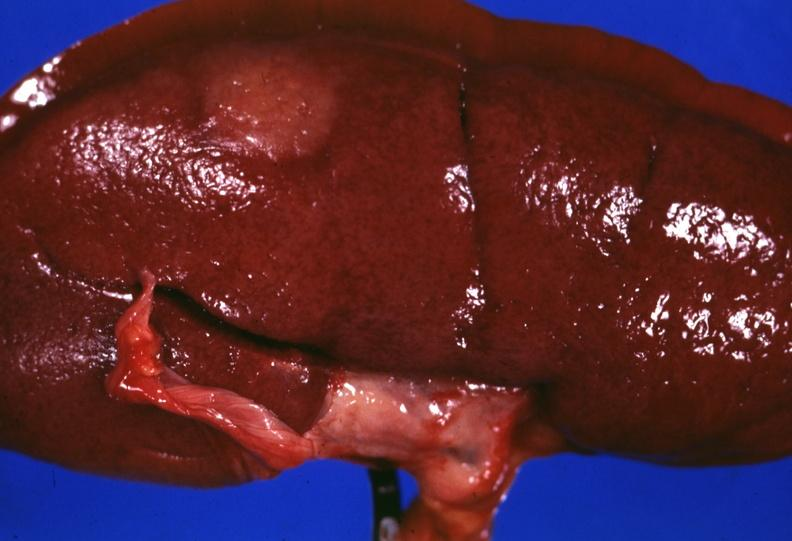s hypopharyngeal edema stripped unusual?
Answer the question using a single word or phrase. No 